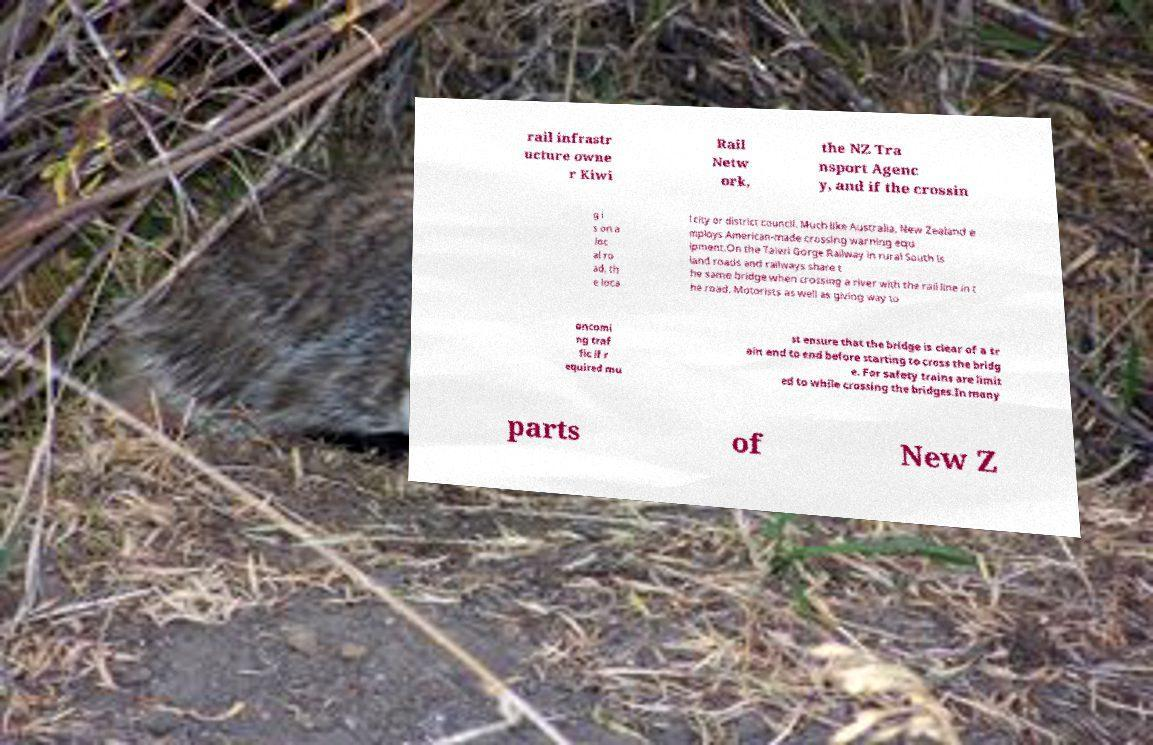There's text embedded in this image that I need extracted. Can you transcribe it verbatim? rail infrastr ucture owne r Kiwi Rail Netw ork, the NZ Tra nsport Agenc y, and if the crossin g i s on a loc al ro ad, th e loca l city or district council. Much like Australia, New Zealand e mploys American-made crossing warning equ ipment.On the Taieri Gorge Railway in rural South Is land roads and railways share t he same bridge when crossing a river with the rail line in t he road. Motorists as well as giving way to oncomi ng traf fic if r equired mu st ensure that the bridge is clear of a tr ain end to end before starting to cross the bridg e. For safety trains are limit ed to while crossing the bridges.In many parts of New Z 